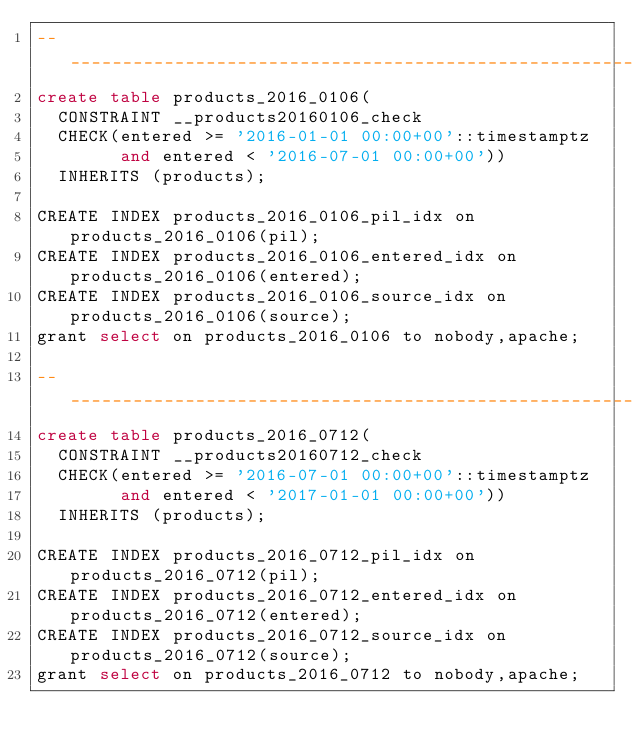<code> <loc_0><loc_0><loc_500><loc_500><_SQL_>-- ________________________________________________________________
create table products_2016_0106( 
  CONSTRAINT __products20160106_check 
  CHECK(entered >= '2016-01-01 00:00+00'::timestamptz 
        and entered < '2016-07-01 00:00+00')) 
  INHERITS (products);

CREATE INDEX products_2016_0106_pil_idx on products_2016_0106(pil);
CREATE INDEX products_2016_0106_entered_idx on products_2016_0106(entered);
CREATE INDEX products_2016_0106_source_idx on products_2016_0106(source);
grant select on products_2016_0106 to nobody,apache;

-- ________________________________________________________________
create table products_2016_0712( 
  CONSTRAINT __products20160712_check 
  CHECK(entered >= '2016-07-01 00:00+00'::timestamptz 
        and entered < '2017-01-01 00:00+00')) 
  INHERITS (products);

CREATE INDEX products_2016_0712_pil_idx on products_2016_0712(pil);
CREATE INDEX products_2016_0712_entered_idx on products_2016_0712(entered);
CREATE INDEX products_2016_0712_source_idx on products_2016_0712(source);
grant select on products_2016_0712 to nobody,apache;
</code> 